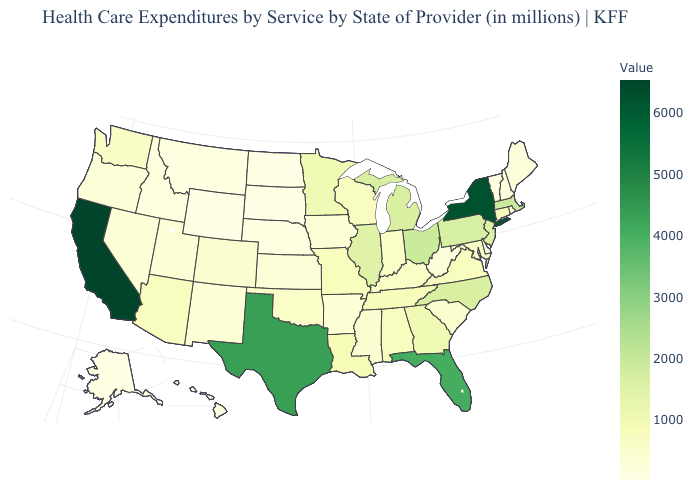Among the states that border Rhode Island , which have the highest value?
Write a very short answer. Massachusetts. Among the states that border Rhode Island , which have the lowest value?
Answer briefly. Connecticut. Which states have the lowest value in the USA?
Be succinct. South Dakota. Which states have the highest value in the USA?
Short answer required. California. Which states have the lowest value in the USA?
Concise answer only. South Dakota. 